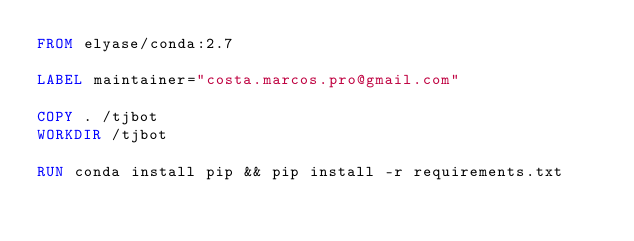<code> <loc_0><loc_0><loc_500><loc_500><_Dockerfile_>FROM elyase/conda:2.7

LABEL maintainer="costa.marcos.pro@gmail.com"

COPY . /tjbot
WORKDIR /tjbot

RUN conda install pip && pip install -r requirements.txt
</code> 